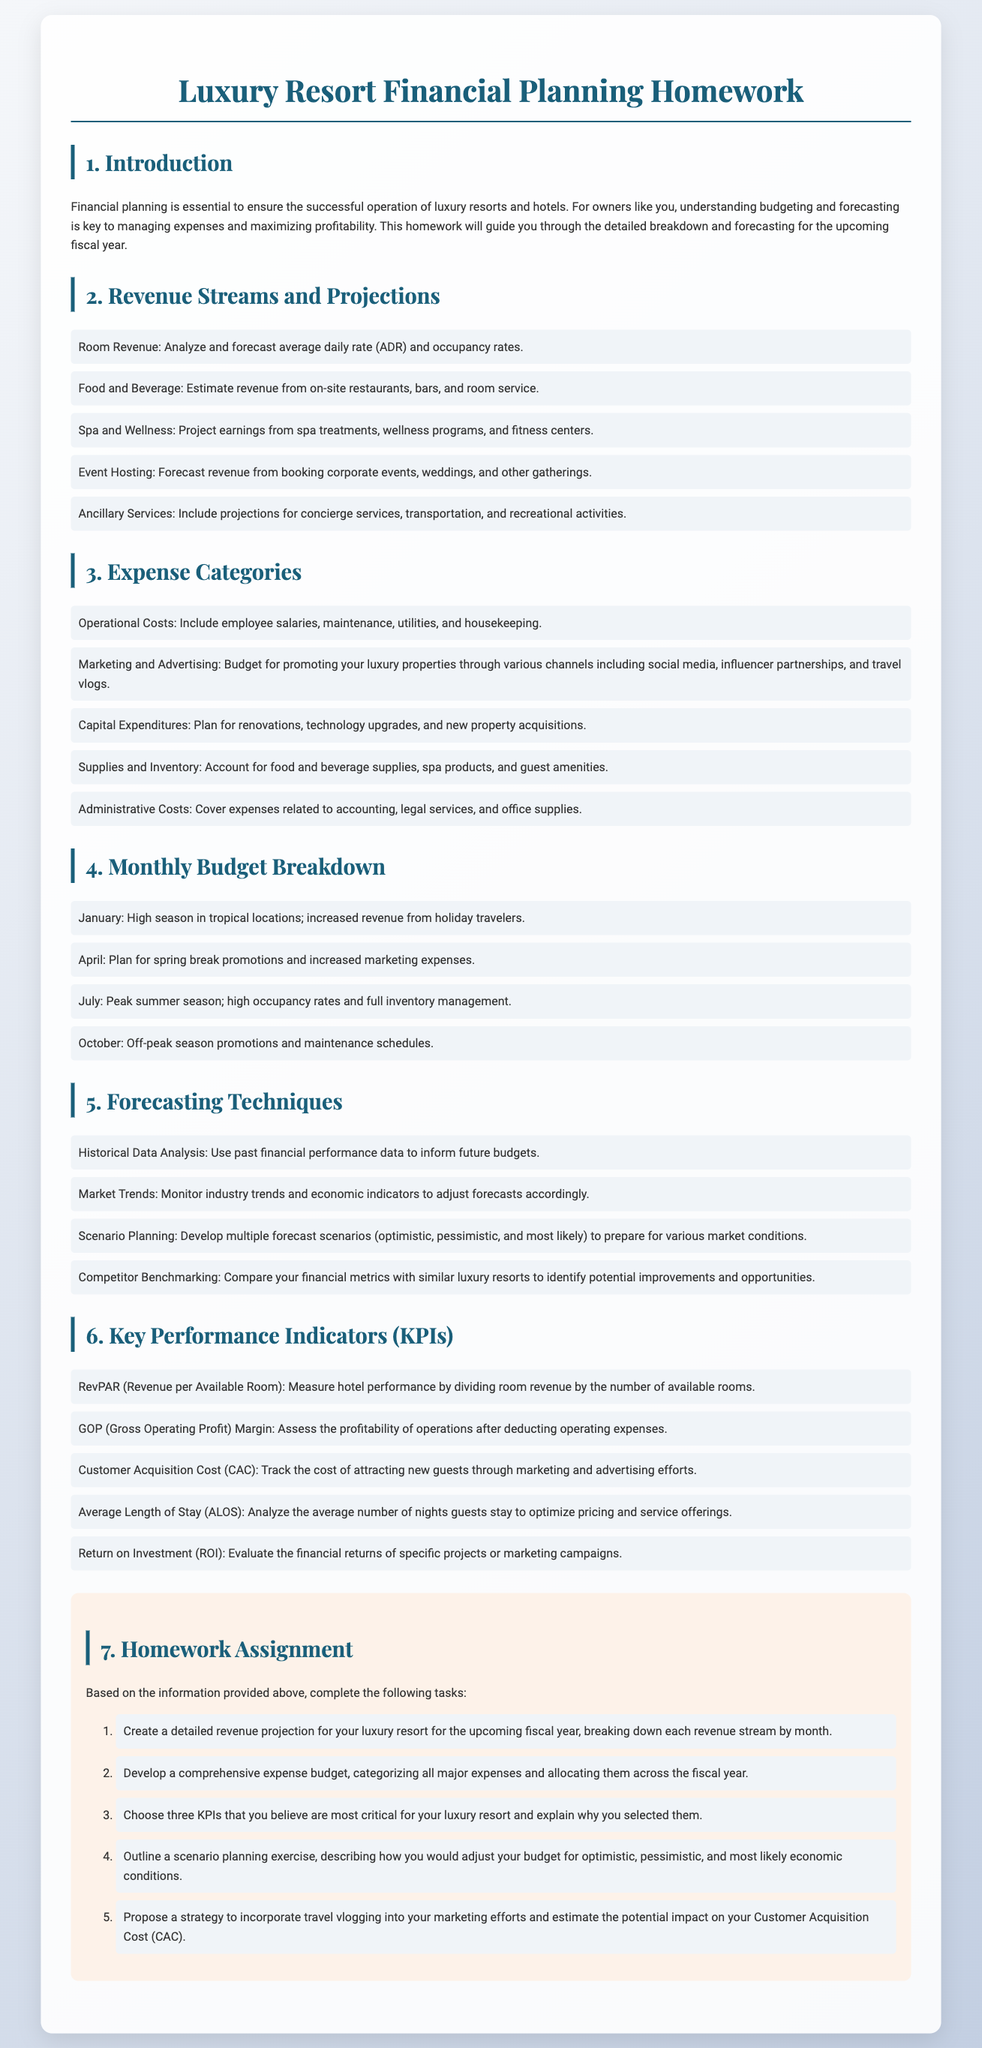What is the title of the document? The title of the document is mentioned in the header section as "Luxury Resort Financial Planning Homework."
Answer: Luxury Resort Financial Planning Homework What is the main purpose of financial planning? The main purpose is summarized in the introduction that states it is essential for the successful operation of luxury resorts and hotels.
Answer: Ensure successful operation What are the five revenue streams mentioned? The document lists five revenue streams which include room revenue, food and beverage, spa and wellness, event hosting, and ancillary services.
Answer: Room revenue, food and beverage, spa and wellness, event hosting, ancillary services What does RevPAR stand for? The abbreviation RevPAR is defined in the KPIs section as "Revenue per Available Room."
Answer: Revenue per Available Room How many months does the monthly budget breakdown cover? The monthly budget breakdown includes specific mentions of four months in the document.
Answer: Four months Which category includes expenses for promoting properties through influencers? The expenses for promoting properties include marketing and advertising in the Expense Categories section.
Answer: Marketing and Advertising What is one forecasting technique mentioned? One of the forecasting techniques listed in the document is "Historical Data Analysis."
Answer: Historical Data Analysis List one key performance indicator that measures the cost to attract guests. The indicator that measures this cost is stated as "Customer Acquisition Cost (CAC)."
Answer: Customer Acquisition Cost What task involves scenario planning? The task that involves scenario planning is outlined in the homework assignment referring to preparing different budget adjustments.
Answer: Adjust budget for scenarios Which section discusses the importance of budget allocation? The section on Expense Categories discusses the importance of budget allocation across major expenses.
Answer: Expense Categories 